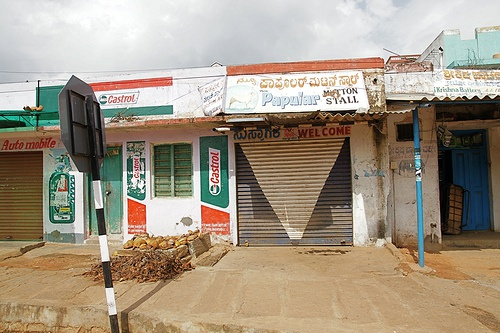Describe the objects in this image and their specific colors. I can see a stop sign in lightgray, black, and gray tones in this image. 